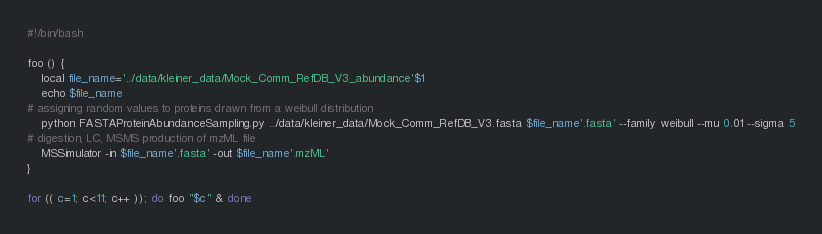<code> <loc_0><loc_0><loc_500><loc_500><_Bash_>#!/bin/bash

foo () {
	local file_name='../data/kleiner_data/Mock_Comm_RefDB_V3_abundance'$1
	echo $file_name
# assigning random values to proteins drawn from a weibull distribution
	python FASTAProteinAbundanceSampling.py ../data/kleiner_data/Mock_Comm_RefDB_V3.fasta $file_name'.fasta' --family weibull --mu 0.01 --sigma 5
# digestion, LC, MSMS production of mzML file
	MSSimulator -in $file_name'.fasta' -out $file_name'.mzML'
}

for (( c=1; c<11; c++ )); do foo "$c" & done

</code> 